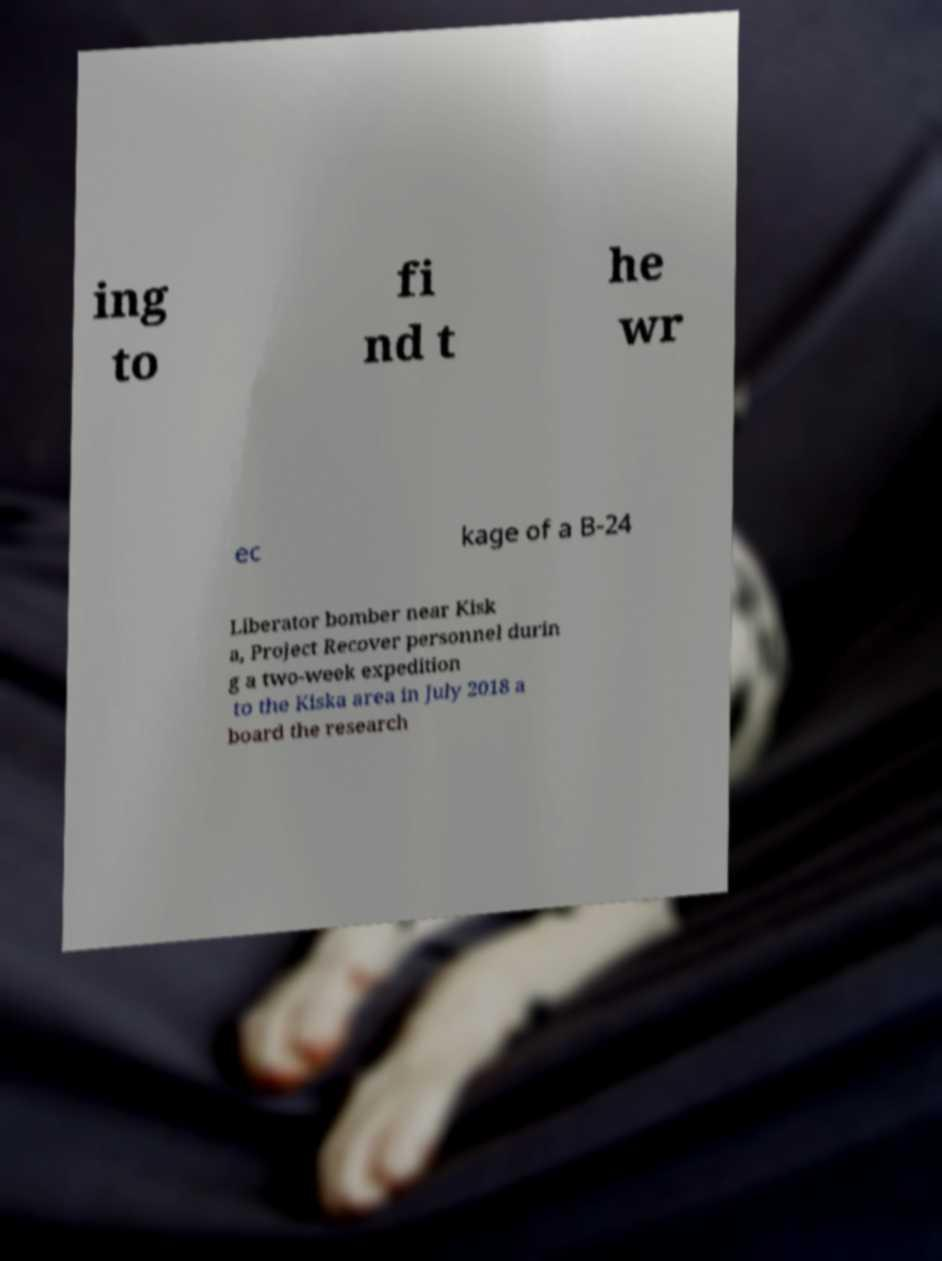What messages or text are displayed in this image? I need them in a readable, typed format. ing to fi nd t he wr ec kage of a B-24 Liberator bomber near Kisk a, Project Recover personnel durin g a two-week expedition to the Kiska area in July 2018 a board the research 